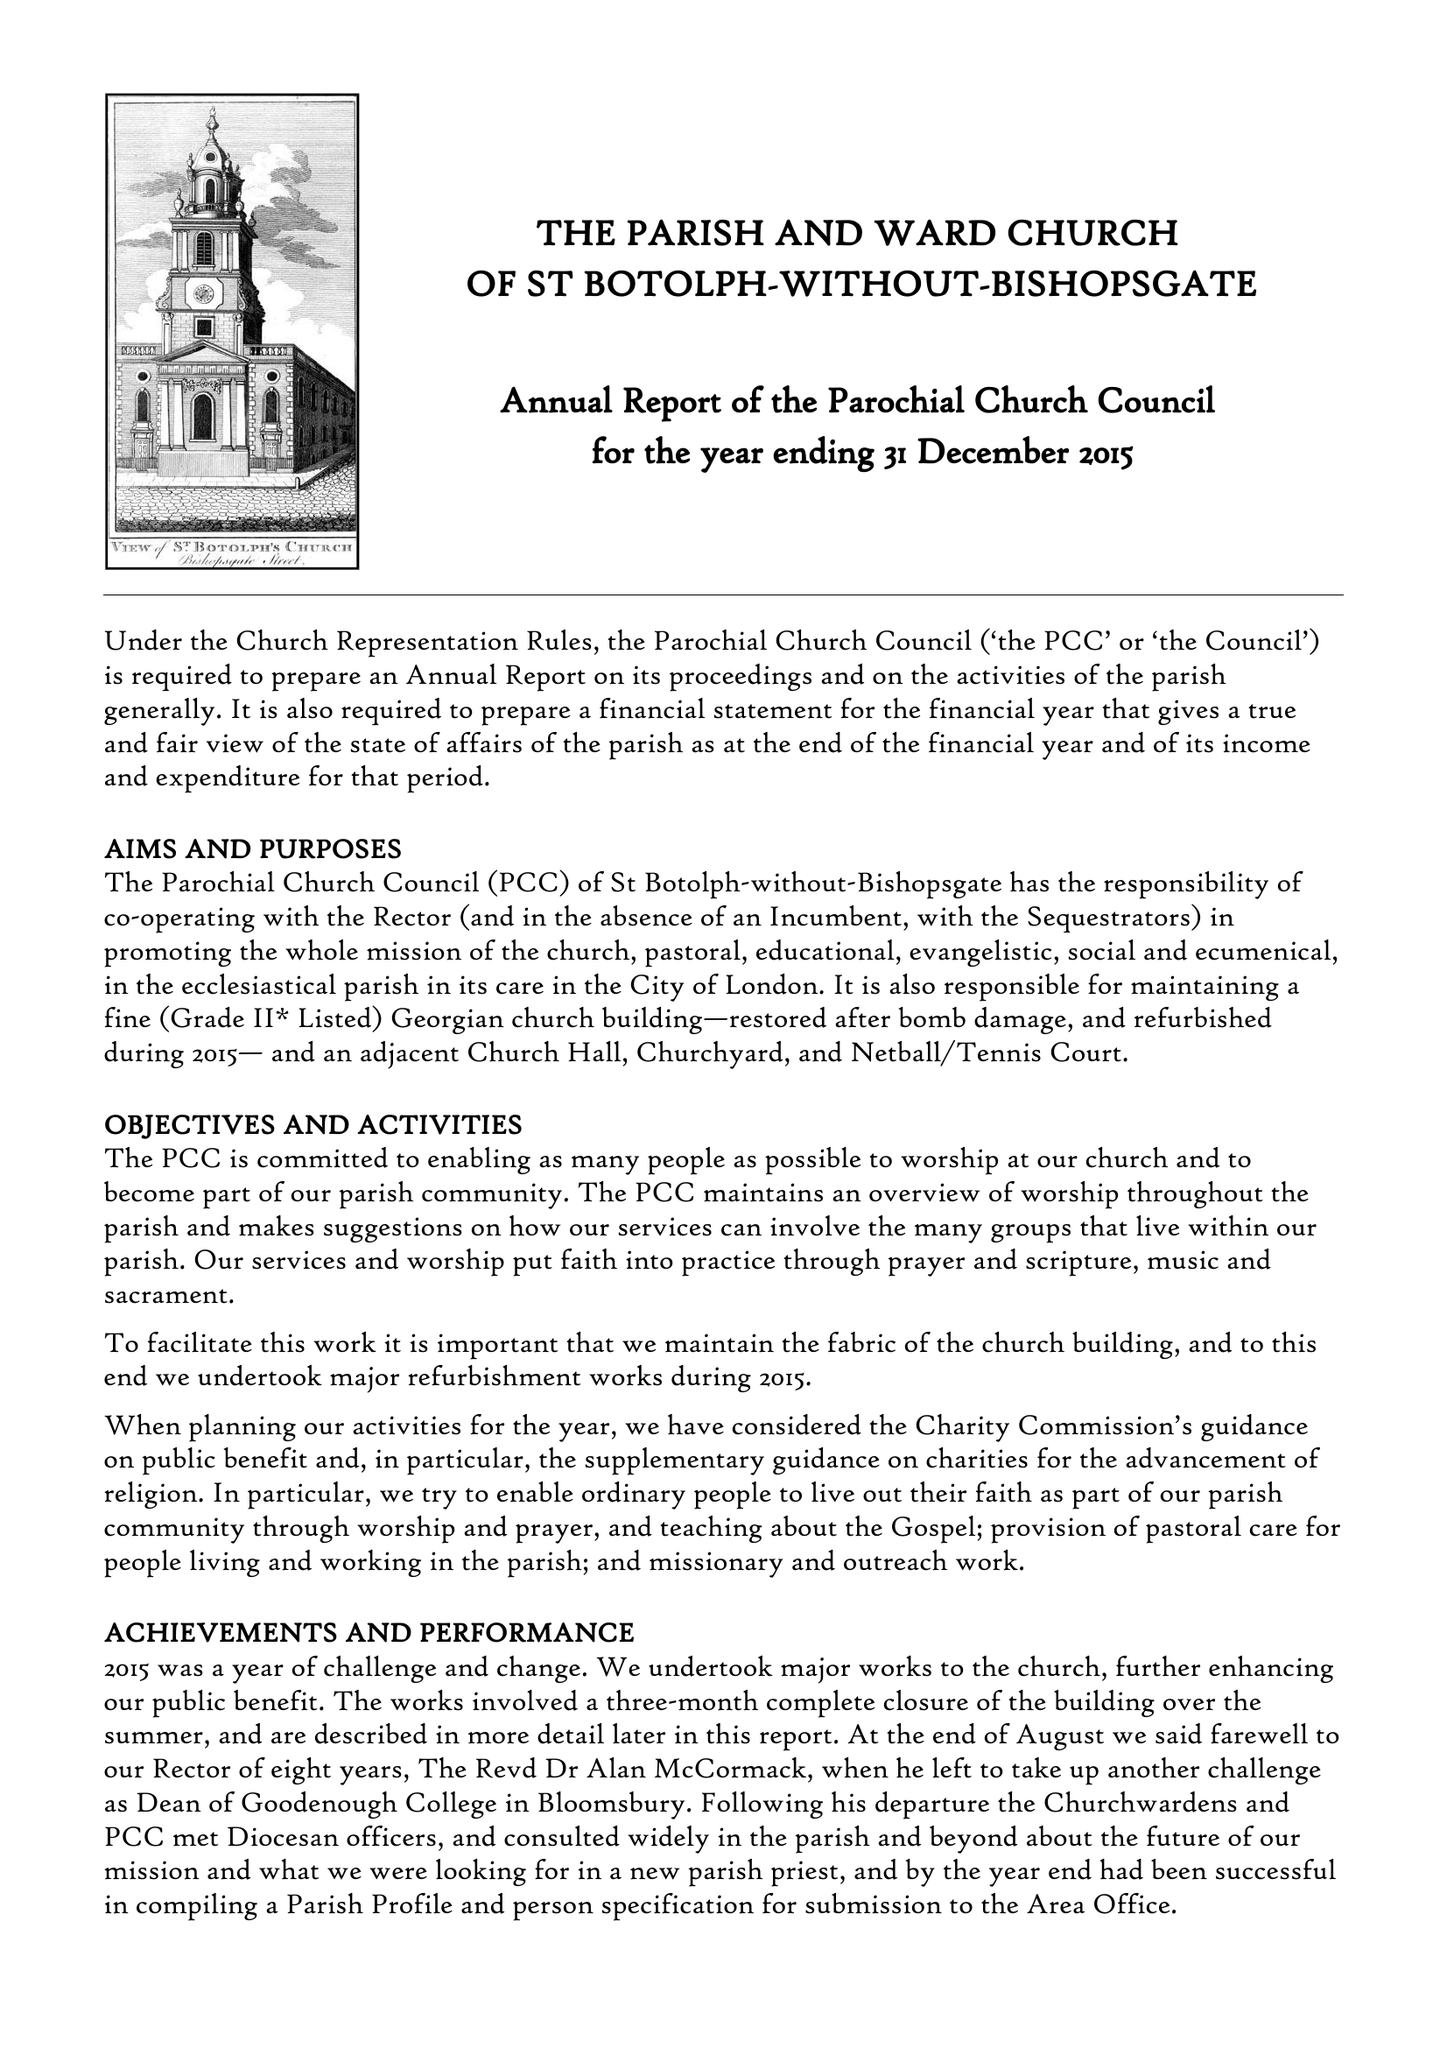What is the value for the address__post_town?
Answer the question using a single word or phrase. LONDON 